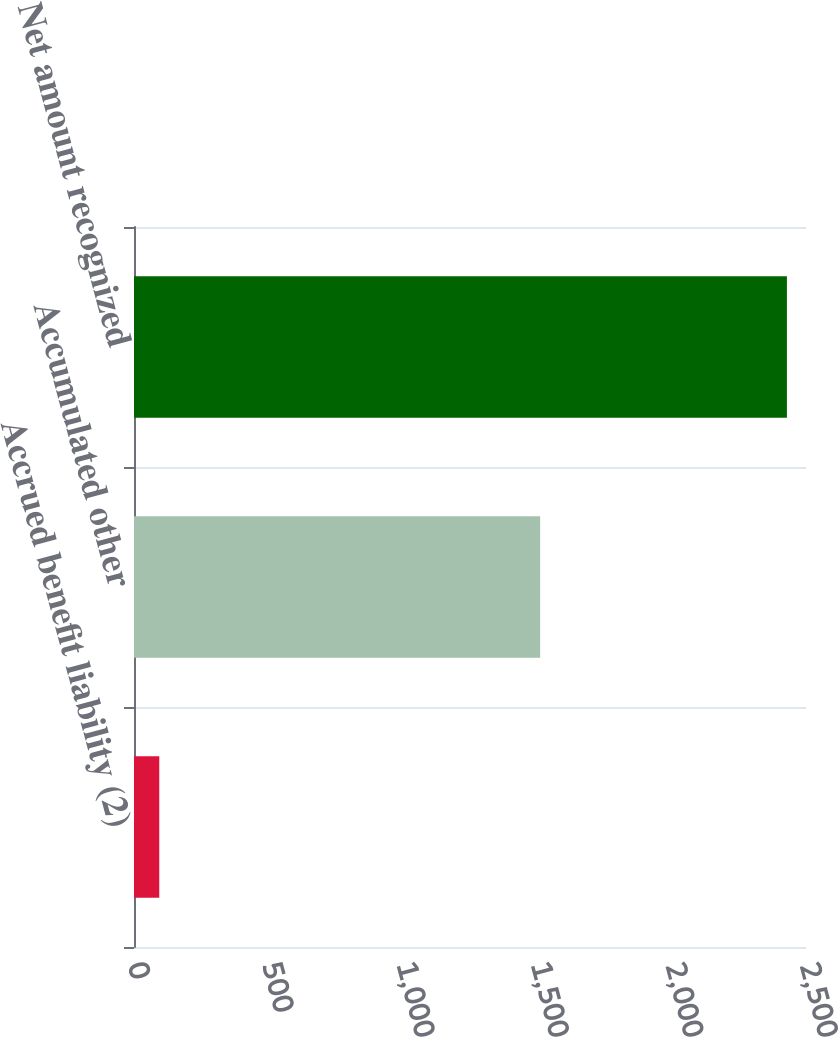Convert chart to OTSL. <chart><loc_0><loc_0><loc_500><loc_500><bar_chart><fcel>Accrued benefit liability (2)<fcel>Accumulated other<fcel>Net amount recognized<nl><fcel>94<fcel>1511<fcel>2429<nl></chart> 